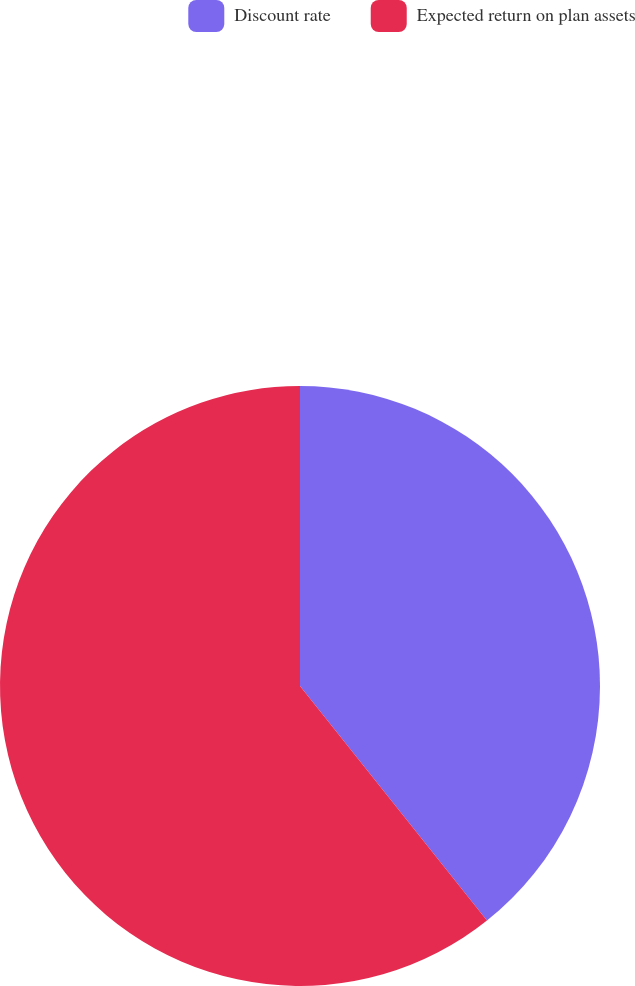<chart> <loc_0><loc_0><loc_500><loc_500><pie_chart><fcel>Discount rate<fcel>Expected return on plan assets<nl><fcel>39.29%<fcel>60.71%<nl></chart> 